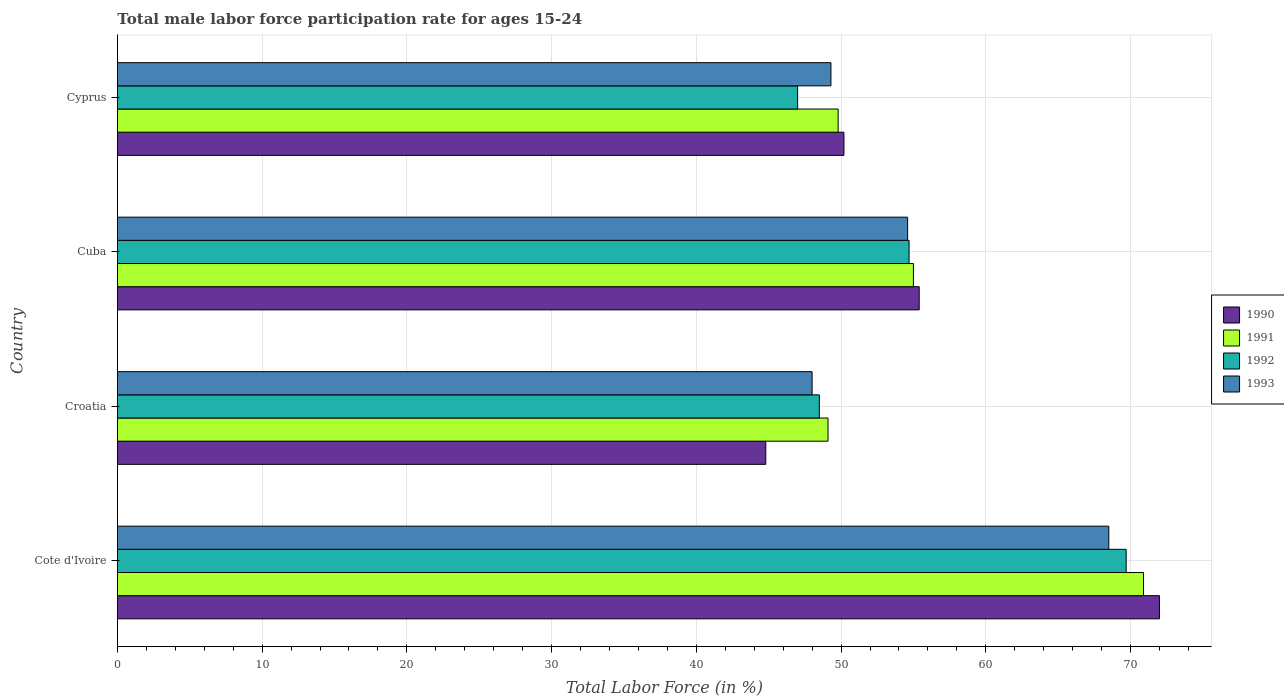How many different coloured bars are there?
Offer a terse response. 4. Are the number of bars per tick equal to the number of legend labels?
Your response must be concise. Yes. Are the number of bars on each tick of the Y-axis equal?
Ensure brevity in your answer.  Yes. How many bars are there on the 4th tick from the top?
Offer a very short reply. 4. What is the label of the 4th group of bars from the top?
Offer a very short reply. Cote d'Ivoire. What is the male labor force participation rate in 1990 in Cote d'Ivoire?
Offer a very short reply. 72. Across all countries, what is the maximum male labor force participation rate in 1991?
Offer a very short reply. 70.9. Across all countries, what is the minimum male labor force participation rate in 1991?
Your answer should be compact. 49.1. In which country was the male labor force participation rate in 1991 maximum?
Ensure brevity in your answer.  Cote d'Ivoire. In which country was the male labor force participation rate in 1991 minimum?
Keep it short and to the point. Croatia. What is the total male labor force participation rate in 1993 in the graph?
Keep it short and to the point. 220.4. What is the difference between the male labor force participation rate in 1992 in Cote d'Ivoire and that in Croatia?
Ensure brevity in your answer.  21.2. What is the difference between the male labor force participation rate in 1993 in Cyprus and the male labor force participation rate in 1990 in Cote d'Ivoire?
Make the answer very short. -22.7. What is the average male labor force participation rate in 1990 per country?
Provide a succinct answer. 55.6. What is the difference between the male labor force participation rate in 1992 and male labor force participation rate in 1993 in Croatia?
Make the answer very short. 0.5. What is the ratio of the male labor force participation rate in 1993 in Croatia to that in Cyprus?
Keep it short and to the point. 0.97. What is the difference between the highest and the second highest male labor force participation rate in 1990?
Your response must be concise. 16.6. What is the difference between the highest and the lowest male labor force participation rate in 1991?
Your answer should be very brief. 21.8. Is the sum of the male labor force participation rate in 1990 in Cote d'Ivoire and Croatia greater than the maximum male labor force participation rate in 1993 across all countries?
Offer a very short reply. Yes. Is it the case that in every country, the sum of the male labor force participation rate in 1991 and male labor force participation rate in 1992 is greater than the sum of male labor force participation rate in 1993 and male labor force participation rate in 1990?
Your answer should be compact. No. What does the 4th bar from the top in Croatia represents?
Ensure brevity in your answer.  1990. Is it the case that in every country, the sum of the male labor force participation rate in 1992 and male labor force participation rate in 1991 is greater than the male labor force participation rate in 1990?
Your response must be concise. Yes. Where does the legend appear in the graph?
Your answer should be very brief. Center right. What is the title of the graph?
Ensure brevity in your answer.  Total male labor force participation rate for ages 15-24. Does "2012" appear as one of the legend labels in the graph?
Ensure brevity in your answer.  No. What is the label or title of the X-axis?
Your response must be concise. Total Labor Force (in %). What is the label or title of the Y-axis?
Ensure brevity in your answer.  Country. What is the Total Labor Force (in %) in 1990 in Cote d'Ivoire?
Offer a terse response. 72. What is the Total Labor Force (in %) in 1991 in Cote d'Ivoire?
Provide a succinct answer. 70.9. What is the Total Labor Force (in %) of 1992 in Cote d'Ivoire?
Ensure brevity in your answer.  69.7. What is the Total Labor Force (in %) of 1993 in Cote d'Ivoire?
Offer a very short reply. 68.5. What is the Total Labor Force (in %) of 1990 in Croatia?
Provide a succinct answer. 44.8. What is the Total Labor Force (in %) in 1991 in Croatia?
Your response must be concise. 49.1. What is the Total Labor Force (in %) of 1992 in Croatia?
Give a very brief answer. 48.5. What is the Total Labor Force (in %) in 1993 in Croatia?
Your answer should be very brief. 48. What is the Total Labor Force (in %) in 1990 in Cuba?
Your answer should be compact. 55.4. What is the Total Labor Force (in %) in 1992 in Cuba?
Offer a very short reply. 54.7. What is the Total Labor Force (in %) in 1993 in Cuba?
Provide a succinct answer. 54.6. What is the Total Labor Force (in %) in 1990 in Cyprus?
Your response must be concise. 50.2. What is the Total Labor Force (in %) in 1991 in Cyprus?
Make the answer very short. 49.8. What is the Total Labor Force (in %) of 1993 in Cyprus?
Keep it short and to the point. 49.3. Across all countries, what is the maximum Total Labor Force (in %) in 1990?
Provide a succinct answer. 72. Across all countries, what is the maximum Total Labor Force (in %) of 1991?
Give a very brief answer. 70.9. Across all countries, what is the maximum Total Labor Force (in %) in 1992?
Your answer should be very brief. 69.7. Across all countries, what is the maximum Total Labor Force (in %) in 1993?
Give a very brief answer. 68.5. Across all countries, what is the minimum Total Labor Force (in %) in 1990?
Your answer should be very brief. 44.8. Across all countries, what is the minimum Total Labor Force (in %) of 1991?
Your answer should be very brief. 49.1. Across all countries, what is the minimum Total Labor Force (in %) of 1993?
Ensure brevity in your answer.  48. What is the total Total Labor Force (in %) of 1990 in the graph?
Make the answer very short. 222.4. What is the total Total Labor Force (in %) of 1991 in the graph?
Keep it short and to the point. 224.8. What is the total Total Labor Force (in %) in 1992 in the graph?
Make the answer very short. 219.9. What is the total Total Labor Force (in %) of 1993 in the graph?
Give a very brief answer. 220.4. What is the difference between the Total Labor Force (in %) in 1990 in Cote d'Ivoire and that in Croatia?
Give a very brief answer. 27.2. What is the difference between the Total Labor Force (in %) in 1991 in Cote d'Ivoire and that in Croatia?
Provide a short and direct response. 21.8. What is the difference between the Total Labor Force (in %) of 1992 in Cote d'Ivoire and that in Croatia?
Offer a very short reply. 21.2. What is the difference between the Total Labor Force (in %) of 1990 in Cote d'Ivoire and that in Cuba?
Offer a terse response. 16.6. What is the difference between the Total Labor Force (in %) of 1992 in Cote d'Ivoire and that in Cuba?
Provide a short and direct response. 15. What is the difference between the Total Labor Force (in %) in 1990 in Cote d'Ivoire and that in Cyprus?
Keep it short and to the point. 21.8. What is the difference between the Total Labor Force (in %) in 1991 in Cote d'Ivoire and that in Cyprus?
Offer a terse response. 21.1. What is the difference between the Total Labor Force (in %) in 1992 in Cote d'Ivoire and that in Cyprus?
Offer a very short reply. 22.7. What is the difference between the Total Labor Force (in %) of 1991 in Croatia and that in Cuba?
Ensure brevity in your answer.  -5.9. What is the difference between the Total Labor Force (in %) in 1992 in Croatia and that in Cuba?
Provide a short and direct response. -6.2. What is the difference between the Total Labor Force (in %) in 1993 in Croatia and that in Cuba?
Keep it short and to the point. -6.6. What is the difference between the Total Labor Force (in %) of 1990 in Croatia and that in Cyprus?
Your answer should be compact. -5.4. What is the difference between the Total Labor Force (in %) of 1991 in Croatia and that in Cyprus?
Provide a succinct answer. -0.7. What is the difference between the Total Labor Force (in %) of 1992 in Croatia and that in Cyprus?
Give a very brief answer. 1.5. What is the difference between the Total Labor Force (in %) of 1993 in Croatia and that in Cyprus?
Provide a succinct answer. -1.3. What is the difference between the Total Labor Force (in %) in 1990 in Cuba and that in Cyprus?
Offer a very short reply. 5.2. What is the difference between the Total Labor Force (in %) of 1992 in Cuba and that in Cyprus?
Offer a terse response. 7.7. What is the difference between the Total Labor Force (in %) in 1990 in Cote d'Ivoire and the Total Labor Force (in %) in 1991 in Croatia?
Your response must be concise. 22.9. What is the difference between the Total Labor Force (in %) of 1990 in Cote d'Ivoire and the Total Labor Force (in %) of 1992 in Croatia?
Ensure brevity in your answer.  23.5. What is the difference between the Total Labor Force (in %) in 1990 in Cote d'Ivoire and the Total Labor Force (in %) in 1993 in Croatia?
Provide a short and direct response. 24. What is the difference between the Total Labor Force (in %) of 1991 in Cote d'Ivoire and the Total Labor Force (in %) of 1992 in Croatia?
Give a very brief answer. 22.4. What is the difference between the Total Labor Force (in %) in 1991 in Cote d'Ivoire and the Total Labor Force (in %) in 1993 in Croatia?
Keep it short and to the point. 22.9. What is the difference between the Total Labor Force (in %) in 1992 in Cote d'Ivoire and the Total Labor Force (in %) in 1993 in Croatia?
Provide a succinct answer. 21.7. What is the difference between the Total Labor Force (in %) in 1991 in Cote d'Ivoire and the Total Labor Force (in %) in 1992 in Cuba?
Give a very brief answer. 16.2. What is the difference between the Total Labor Force (in %) in 1991 in Cote d'Ivoire and the Total Labor Force (in %) in 1993 in Cuba?
Offer a terse response. 16.3. What is the difference between the Total Labor Force (in %) in 1990 in Cote d'Ivoire and the Total Labor Force (in %) in 1991 in Cyprus?
Ensure brevity in your answer.  22.2. What is the difference between the Total Labor Force (in %) of 1990 in Cote d'Ivoire and the Total Labor Force (in %) of 1992 in Cyprus?
Your answer should be compact. 25. What is the difference between the Total Labor Force (in %) of 1990 in Cote d'Ivoire and the Total Labor Force (in %) of 1993 in Cyprus?
Offer a terse response. 22.7. What is the difference between the Total Labor Force (in %) of 1991 in Cote d'Ivoire and the Total Labor Force (in %) of 1992 in Cyprus?
Offer a very short reply. 23.9. What is the difference between the Total Labor Force (in %) in 1991 in Cote d'Ivoire and the Total Labor Force (in %) in 1993 in Cyprus?
Keep it short and to the point. 21.6. What is the difference between the Total Labor Force (in %) in 1992 in Cote d'Ivoire and the Total Labor Force (in %) in 1993 in Cyprus?
Provide a short and direct response. 20.4. What is the difference between the Total Labor Force (in %) in 1990 in Croatia and the Total Labor Force (in %) in 1993 in Cuba?
Provide a succinct answer. -9.8. What is the difference between the Total Labor Force (in %) of 1991 in Croatia and the Total Labor Force (in %) of 1992 in Cuba?
Provide a short and direct response. -5.6. What is the difference between the Total Labor Force (in %) of 1992 in Croatia and the Total Labor Force (in %) of 1993 in Cuba?
Offer a terse response. -6.1. What is the difference between the Total Labor Force (in %) in 1990 in Croatia and the Total Labor Force (in %) in 1993 in Cyprus?
Offer a terse response. -4.5. What is the difference between the Total Labor Force (in %) of 1991 in Croatia and the Total Labor Force (in %) of 1993 in Cyprus?
Offer a very short reply. -0.2. What is the difference between the Total Labor Force (in %) in 1992 in Croatia and the Total Labor Force (in %) in 1993 in Cyprus?
Your answer should be compact. -0.8. What is the difference between the Total Labor Force (in %) of 1990 in Cuba and the Total Labor Force (in %) of 1991 in Cyprus?
Make the answer very short. 5.6. What is the difference between the Total Labor Force (in %) in 1990 in Cuba and the Total Labor Force (in %) in 1993 in Cyprus?
Make the answer very short. 6.1. What is the difference between the Total Labor Force (in %) in 1991 in Cuba and the Total Labor Force (in %) in 1992 in Cyprus?
Provide a short and direct response. 8. What is the difference between the Total Labor Force (in %) of 1991 in Cuba and the Total Labor Force (in %) of 1993 in Cyprus?
Provide a short and direct response. 5.7. What is the difference between the Total Labor Force (in %) of 1992 in Cuba and the Total Labor Force (in %) of 1993 in Cyprus?
Provide a short and direct response. 5.4. What is the average Total Labor Force (in %) in 1990 per country?
Offer a terse response. 55.6. What is the average Total Labor Force (in %) in 1991 per country?
Your answer should be very brief. 56.2. What is the average Total Labor Force (in %) of 1992 per country?
Offer a very short reply. 54.98. What is the average Total Labor Force (in %) in 1993 per country?
Your response must be concise. 55.1. What is the difference between the Total Labor Force (in %) in 1990 and Total Labor Force (in %) in 1991 in Cote d'Ivoire?
Your answer should be compact. 1.1. What is the difference between the Total Labor Force (in %) of 1990 and Total Labor Force (in %) of 1992 in Cote d'Ivoire?
Your response must be concise. 2.3. What is the difference between the Total Labor Force (in %) of 1991 and Total Labor Force (in %) of 1993 in Cote d'Ivoire?
Provide a succinct answer. 2.4. What is the difference between the Total Labor Force (in %) in 1990 and Total Labor Force (in %) in 1991 in Croatia?
Offer a terse response. -4.3. What is the difference between the Total Labor Force (in %) in 1990 and Total Labor Force (in %) in 1993 in Croatia?
Your answer should be very brief. -3.2. What is the difference between the Total Labor Force (in %) in 1991 and Total Labor Force (in %) in 1992 in Croatia?
Your answer should be compact. 0.6. What is the difference between the Total Labor Force (in %) of 1991 and Total Labor Force (in %) of 1993 in Croatia?
Give a very brief answer. 1.1. What is the difference between the Total Labor Force (in %) of 1992 and Total Labor Force (in %) of 1993 in Croatia?
Offer a terse response. 0.5. What is the difference between the Total Labor Force (in %) in 1990 and Total Labor Force (in %) in 1993 in Cuba?
Provide a succinct answer. 0.8. What is the difference between the Total Labor Force (in %) in 1991 and Total Labor Force (in %) in 1993 in Cuba?
Your answer should be compact. 0.4. What is the difference between the Total Labor Force (in %) in 1992 and Total Labor Force (in %) in 1993 in Cuba?
Provide a succinct answer. 0.1. What is the difference between the Total Labor Force (in %) of 1990 and Total Labor Force (in %) of 1991 in Cyprus?
Your response must be concise. 0.4. What is the difference between the Total Labor Force (in %) in 1991 and Total Labor Force (in %) in 1992 in Cyprus?
Make the answer very short. 2.8. What is the difference between the Total Labor Force (in %) of 1992 and Total Labor Force (in %) of 1993 in Cyprus?
Provide a succinct answer. -2.3. What is the ratio of the Total Labor Force (in %) of 1990 in Cote d'Ivoire to that in Croatia?
Provide a short and direct response. 1.61. What is the ratio of the Total Labor Force (in %) in 1991 in Cote d'Ivoire to that in Croatia?
Offer a very short reply. 1.44. What is the ratio of the Total Labor Force (in %) of 1992 in Cote d'Ivoire to that in Croatia?
Your answer should be very brief. 1.44. What is the ratio of the Total Labor Force (in %) of 1993 in Cote d'Ivoire to that in Croatia?
Your answer should be compact. 1.43. What is the ratio of the Total Labor Force (in %) of 1990 in Cote d'Ivoire to that in Cuba?
Make the answer very short. 1.3. What is the ratio of the Total Labor Force (in %) in 1991 in Cote d'Ivoire to that in Cuba?
Offer a terse response. 1.29. What is the ratio of the Total Labor Force (in %) in 1992 in Cote d'Ivoire to that in Cuba?
Provide a succinct answer. 1.27. What is the ratio of the Total Labor Force (in %) of 1993 in Cote d'Ivoire to that in Cuba?
Offer a very short reply. 1.25. What is the ratio of the Total Labor Force (in %) in 1990 in Cote d'Ivoire to that in Cyprus?
Give a very brief answer. 1.43. What is the ratio of the Total Labor Force (in %) of 1991 in Cote d'Ivoire to that in Cyprus?
Make the answer very short. 1.42. What is the ratio of the Total Labor Force (in %) in 1992 in Cote d'Ivoire to that in Cyprus?
Your response must be concise. 1.48. What is the ratio of the Total Labor Force (in %) in 1993 in Cote d'Ivoire to that in Cyprus?
Keep it short and to the point. 1.39. What is the ratio of the Total Labor Force (in %) of 1990 in Croatia to that in Cuba?
Provide a succinct answer. 0.81. What is the ratio of the Total Labor Force (in %) of 1991 in Croatia to that in Cuba?
Make the answer very short. 0.89. What is the ratio of the Total Labor Force (in %) of 1992 in Croatia to that in Cuba?
Make the answer very short. 0.89. What is the ratio of the Total Labor Force (in %) of 1993 in Croatia to that in Cuba?
Offer a terse response. 0.88. What is the ratio of the Total Labor Force (in %) in 1990 in Croatia to that in Cyprus?
Provide a succinct answer. 0.89. What is the ratio of the Total Labor Force (in %) in 1991 in Croatia to that in Cyprus?
Your answer should be very brief. 0.99. What is the ratio of the Total Labor Force (in %) of 1992 in Croatia to that in Cyprus?
Keep it short and to the point. 1.03. What is the ratio of the Total Labor Force (in %) in 1993 in Croatia to that in Cyprus?
Provide a short and direct response. 0.97. What is the ratio of the Total Labor Force (in %) of 1990 in Cuba to that in Cyprus?
Your response must be concise. 1.1. What is the ratio of the Total Labor Force (in %) in 1991 in Cuba to that in Cyprus?
Ensure brevity in your answer.  1.1. What is the ratio of the Total Labor Force (in %) in 1992 in Cuba to that in Cyprus?
Keep it short and to the point. 1.16. What is the ratio of the Total Labor Force (in %) in 1993 in Cuba to that in Cyprus?
Provide a succinct answer. 1.11. What is the difference between the highest and the second highest Total Labor Force (in %) of 1991?
Your answer should be compact. 15.9. What is the difference between the highest and the lowest Total Labor Force (in %) of 1990?
Keep it short and to the point. 27.2. What is the difference between the highest and the lowest Total Labor Force (in %) in 1991?
Make the answer very short. 21.8. What is the difference between the highest and the lowest Total Labor Force (in %) of 1992?
Your response must be concise. 22.7. 